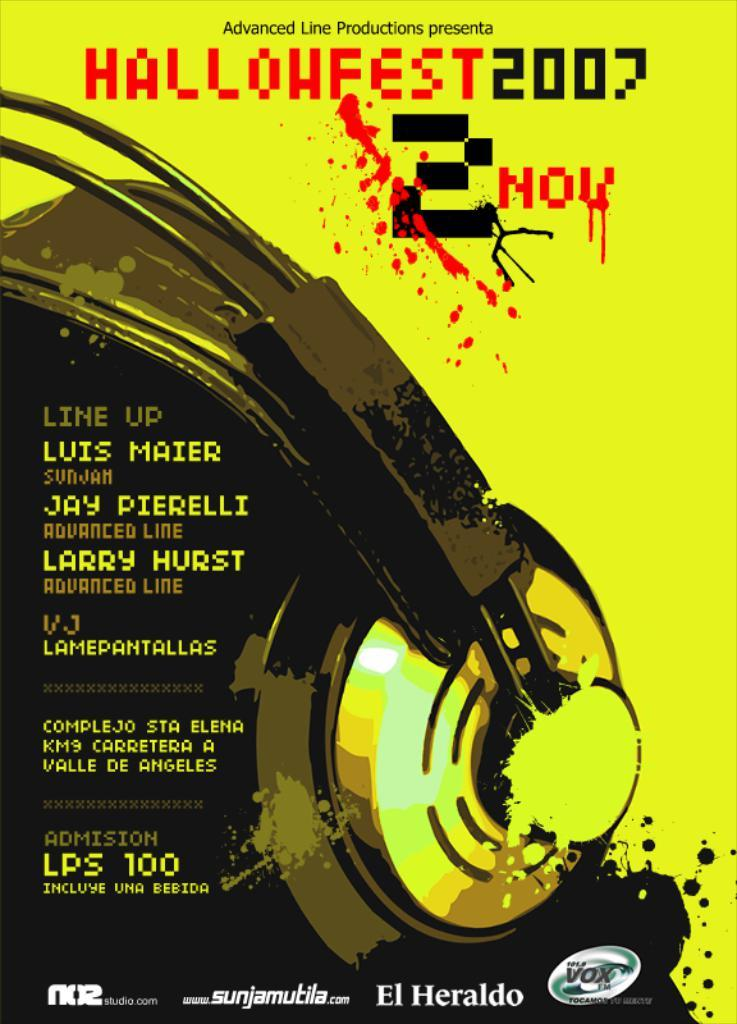<image>
Present a compact description of the photo's key features. poster showing back of head wearing headphones for hallowfest 2007 on nov 2 